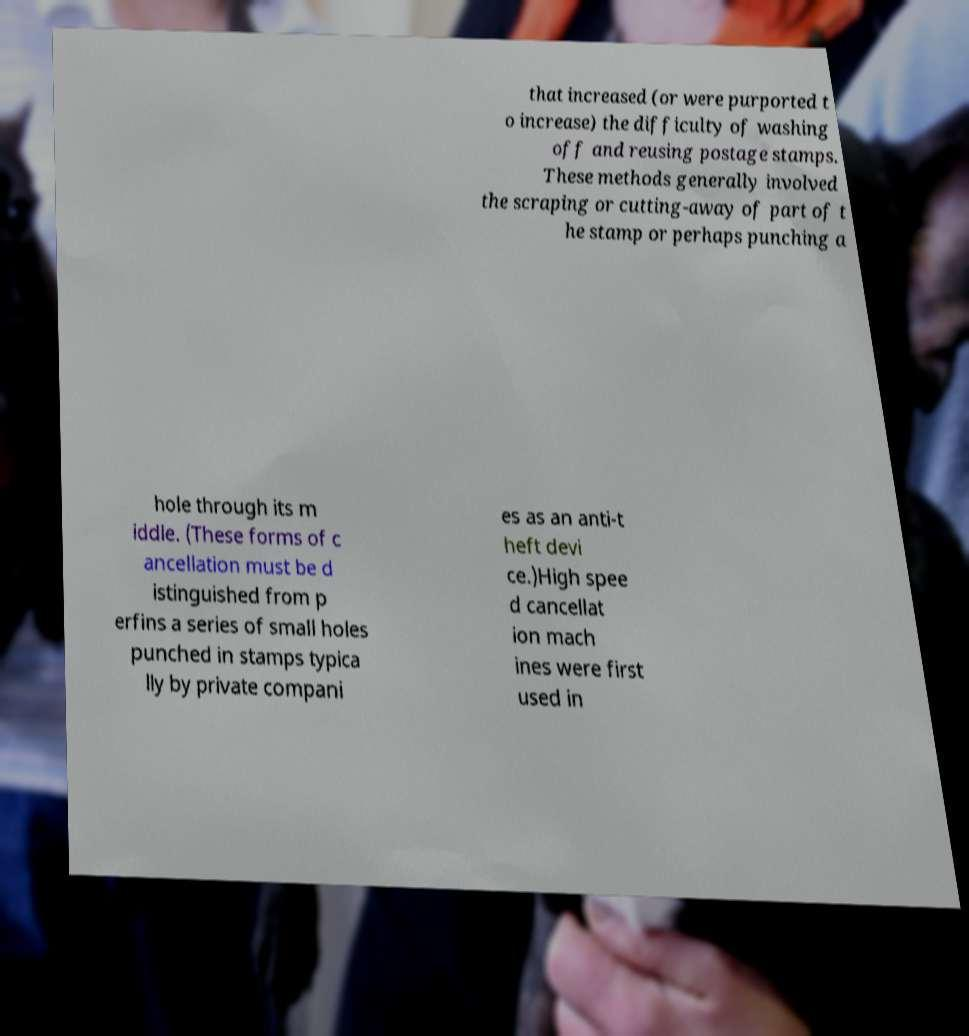Please identify and transcribe the text found in this image. that increased (or were purported t o increase) the difficulty of washing off and reusing postage stamps. These methods generally involved the scraping or cutting-away of part of t he stamp or perhaps punching a hole through its m iddle. (These forms of c ancellation must be d istinguished from p erfins a series of small holes punched in stamps typica lly by private compani es as an anti-t heft devi ce.)High spee d cancellat ion mach ines were first used in 